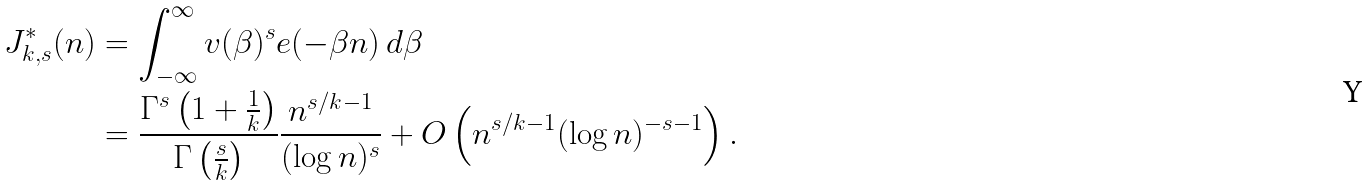Convert formula to latex. <formula><loc_0><loc_0><loc_500><loc_500>J _ { k , s } ^ { * } ( n ) & = \int _ { - \infty } ^ { \infty } v ( \beta ) ^ { s } e ( - \beta n ) \, d \beta \\ & = \frac { \Gamma ^ { s } \left ( 1 + { \frac { 1 } { k } } \right ) } { \Gamma \left ( \frac { s } { k } \right ) } \frac { n ^ { s / k - 1 } } { ( \log n ) ^ { s } } + O \left ( n ^ { s / k - 1 } ( \log n ) ^ { - s - 1 } \right ) .</formula> 